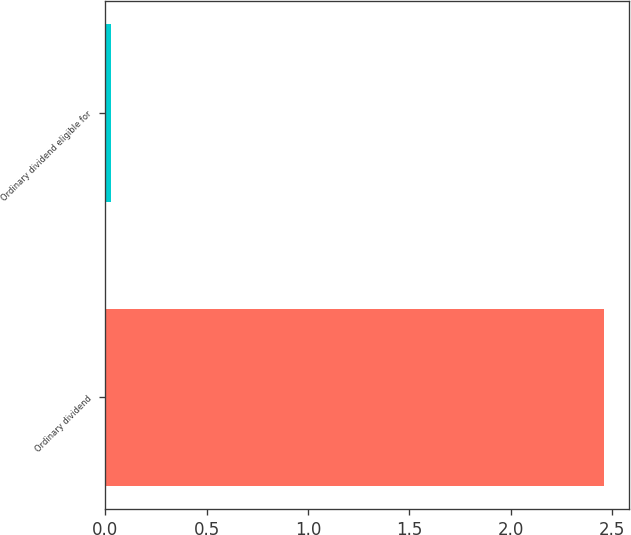Convert chart. <chart><loc_0><loc_0><loc_500><loc_500><bar_chart><fcel>Ordinary dividend<fcel>Ordinary dividend eligible for<nl><fcel>2.46<fcel>0.03<nl></chart> 